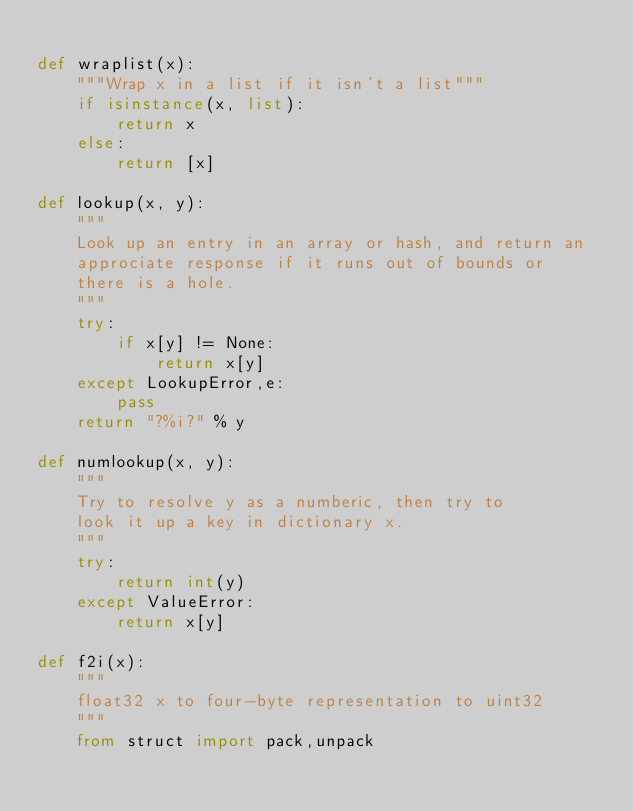Convert code to text. <code><loc_0><loc_0><loc_500><loc_500><_Python_>
def wraplist(x):
    """Wrap x in a list if it isn't a list"""
    if isinstance(x, list):
        return x
    else:
        return [x]

def lookup(x, y):
    """
    Look up an entry in an array or hash, and return an
    approciate response if it runs out of bounds or
    there is a hole.
    """
    try:
        if x[y] != None:
            return x[y]
    except LookupError,e:
        pass
    return "?%i?" % y

def numlookup(x, y):
    """
    Try to resolve y as a numberic, then try to
    look it up a key in dictionary x.
    """
    try:
        return int(y)
    except ValueError:
        return x[y]

def f2i(x):
    """
    float32 x to four-byte representation to uint32
    """
    from struct import pack,unpack</code> 